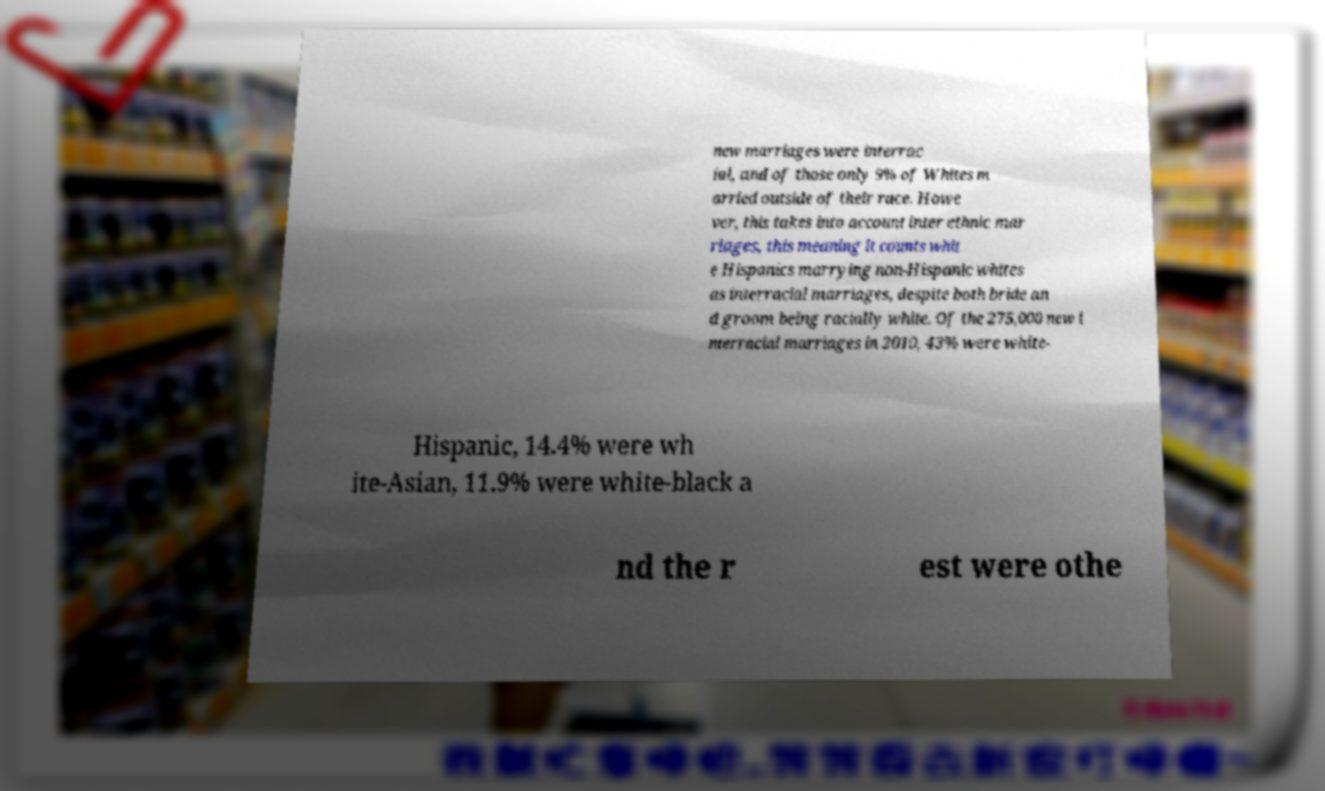Could you extract and type out the text from this image? new marriages were interrac ial, and of those only 9% of Whites m arried outside of their race. Howe ver, this takes into account inter ethnic mar riages, this meaning it counts whit e Hispanics marrying non-Hispanic whites as interracial marriages, despite both bride an d groom being racially white. Of the 275,000 new i nterracial marriages in 2010, 43% were white- Hispanic, 14.4% were wh ite-Asian, 11.9% were white-black a nd the r est were othe 